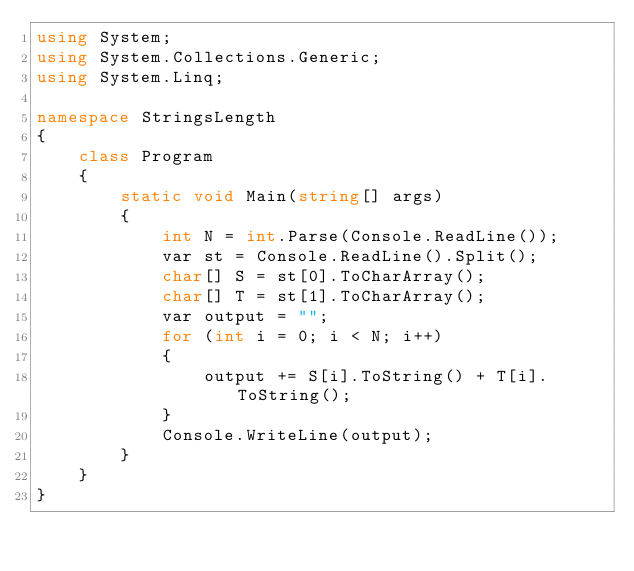Convert code to text. <code><loc_0><loc_0><loc_500><loc_500><_C#_>using System;
using System.Collections.Generic;
using System.Linq;

namespace StringsLength
{
    class Program
    {
        static void Main(string[] args)
        {
            int N = int.Parse(Console.ReadLine());
            var st = Console.ReadLine().Split();
            char[] S = st[0].ToCharArray();
            char[] T = st[1].ToCharArray();
            var output = "";
            for (int i = 0; i < N; i++)
            {
                output += S[i].ToString() + T[i].ToString();
            }
            Console.WriteLine(output);
        }
    }
}
</code> 